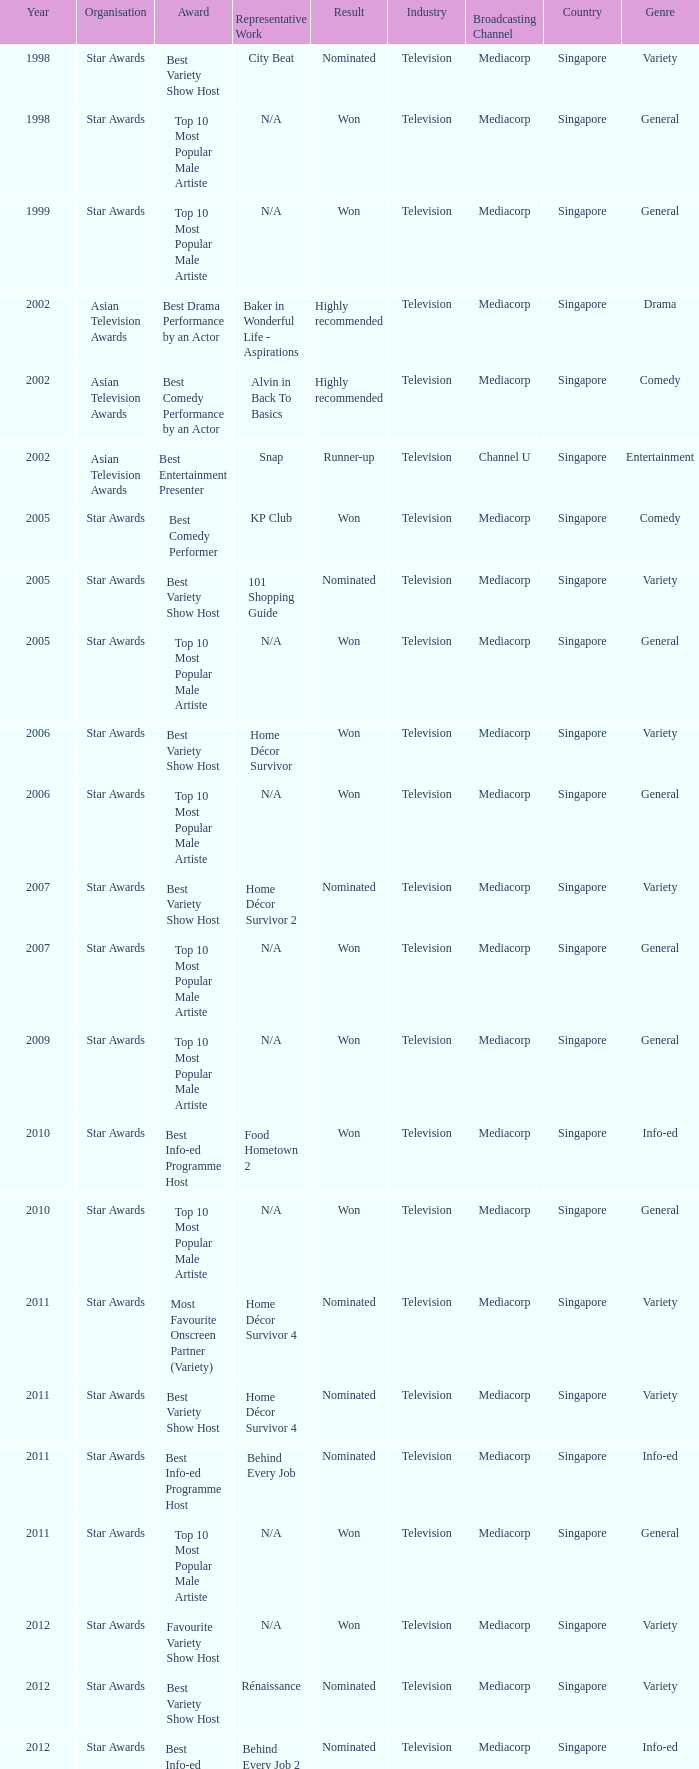What is the award for 1998 with Representative Work of city beat? Best Variety Show Host. 